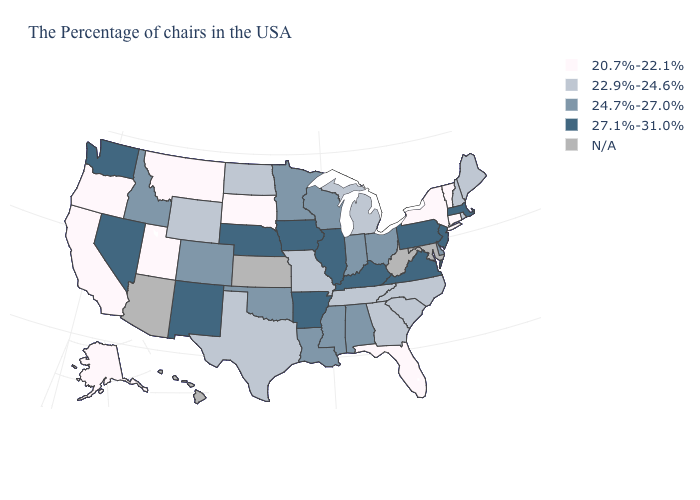What is the lowest value in the West?
Be succinct. 20.7%-22.1%. Is the legend a continuous bar?
Quick response, please. No. How many symbols are there in the legend?
Keep it brief. 5. Among the states that border Ohio , which have the lowest value?
Keep it brief. Michigan. What is the value of Maine?
Keep it brief. 22.9%-24.6%. Does Ohio have the highest value in the USA?
Answer briefly. No. Name the states that have a value in the range N/A?
Keep it brief. Maryland, West Virginia, Kansas, Arizona, Hawaii. Name the states that have a value in the range N/A?
Concise answer only. Maryland, West Virginia, Kansas, Arizona, Hawaii. What is the value of Massachusetts?
Quick response, please. 27.1%-31.0%. Name the states that have a value in the range 24.7%-27.0%?
Give a very brief answer. Delaware, Ohio, Indiana, Alabama, Wisconsin, Mississippi, Louisiana, Minnesota, Oklahoma, Colorado, Idaho. Which states have the lowest value in the USA?
Give a very brief answer. Vermont, Connecticut, New York, Florida, South Dakota, Utah, Montana, California, Oregon, Alaska. Name the states that have a value in the range N/A?
Answer briefly. Maryland, West Virginia, Kansas, Arizona, Hawaii. Does California have the lowest value in the USA?
Be succinct. Yes. Name the states that have a value in the range N/A?
Short answer required. Maryland, West Virginia, Kansas, Arizona, Hawaii. 